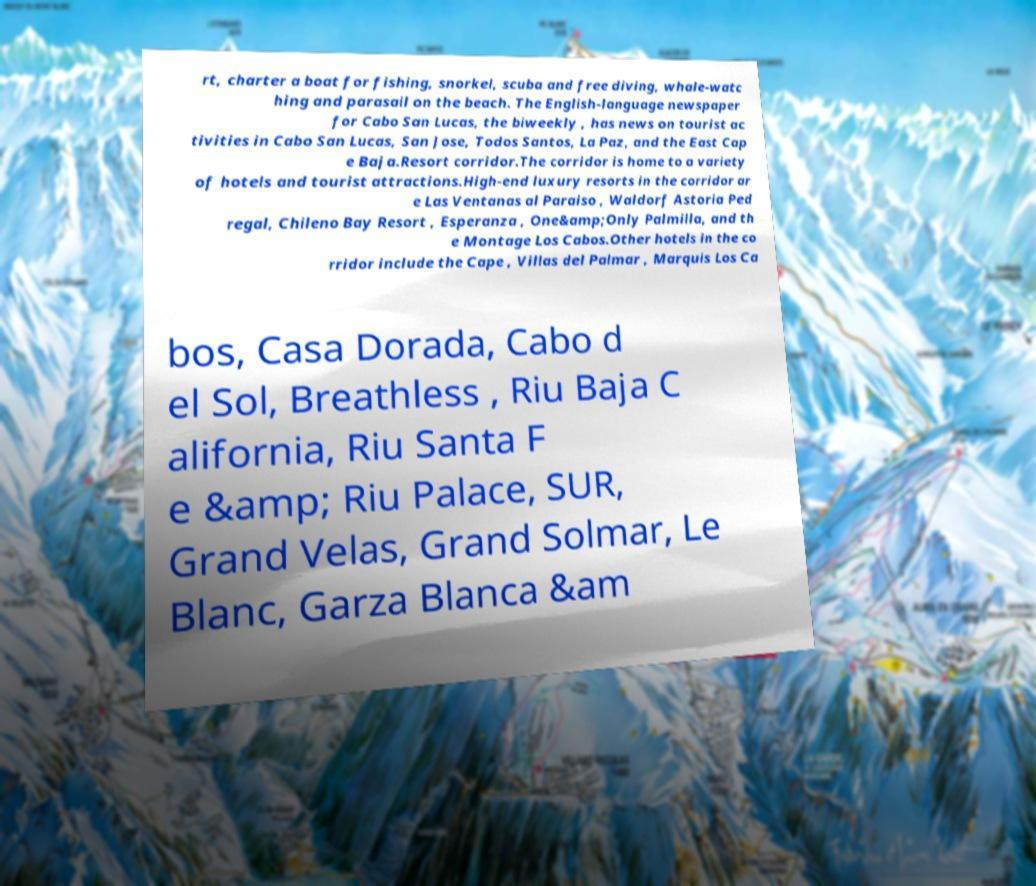Could you extract and type out the text from this image? rt, charter a boat for fishing, snorkel, scuba and free diving, whale-watc hing and parasail on the beach. The English-language newspaper for Cabo San Lucas, the biweekly , has news on tourist ac tivities in Cabo San Lucas, San Jose, Todos Santos, La Paz, and the East Cap e Baja.Resort corridor.The corridor is home to a variety of hotels and tourist attractions.High-end luxury resorts in the corridor ar e Las Ventanas al Paraiso , Waldorf Astoria Ped regal, Chileno Bay Resort , Esperanza , One&amp;Only Palmilla, and th e Montage Los Cabos.Other hotels in the co rridor include the Cape , Villas del Palmar , Marquis Los Ca bos, Casa Dorada, Cabo d el Sol, Breathless , Riu Baja C alifornia, Riu Santa F e &amp; Riu Palace, SUR, Grand Velas, Grand Solmar, Le Blanc, Garza Blanca &am 